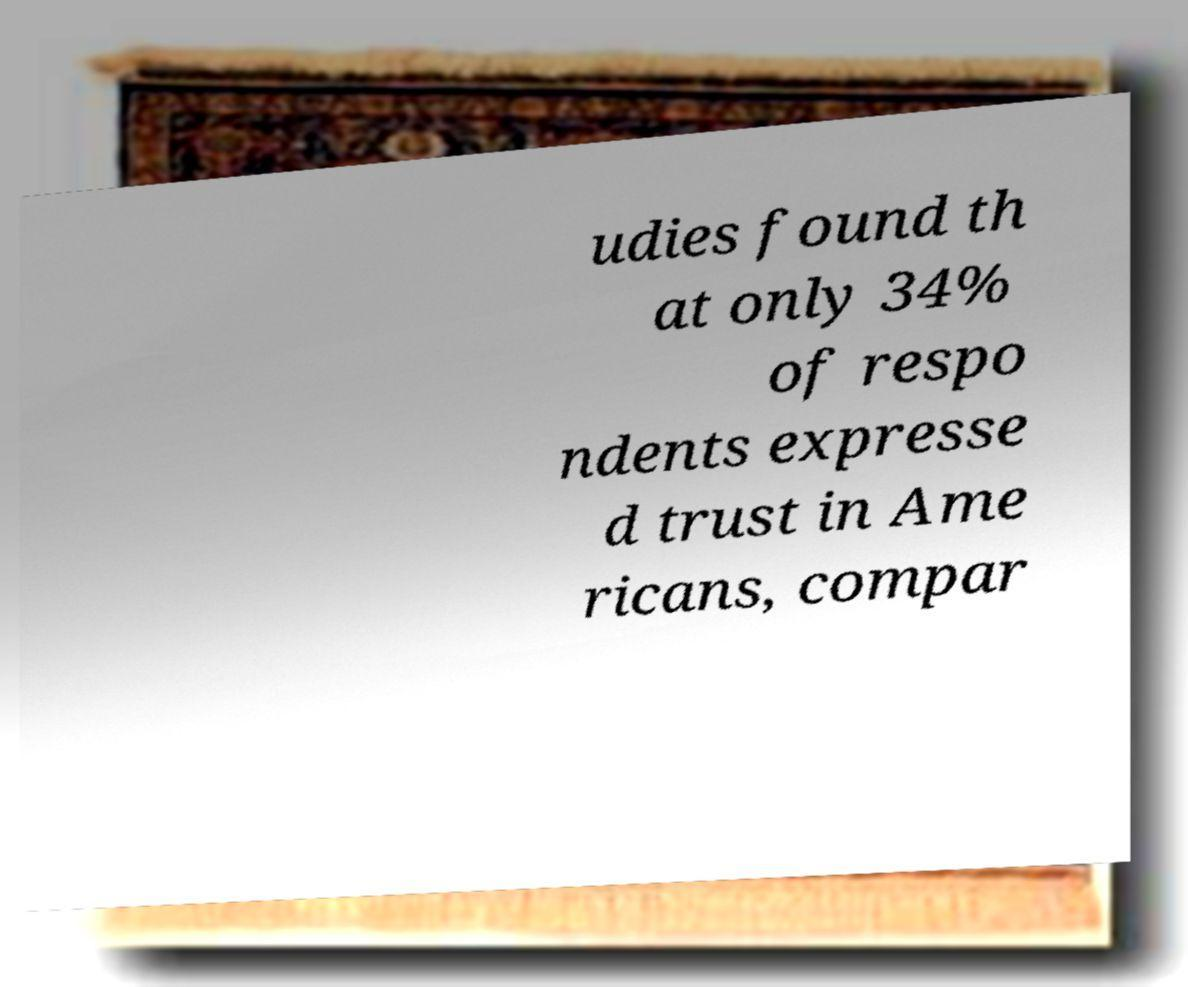I need the written content from this picture converted into text. Can you do that? udies found th at only 34% of respo ndents expresse d trust in Ame ricans, compar 